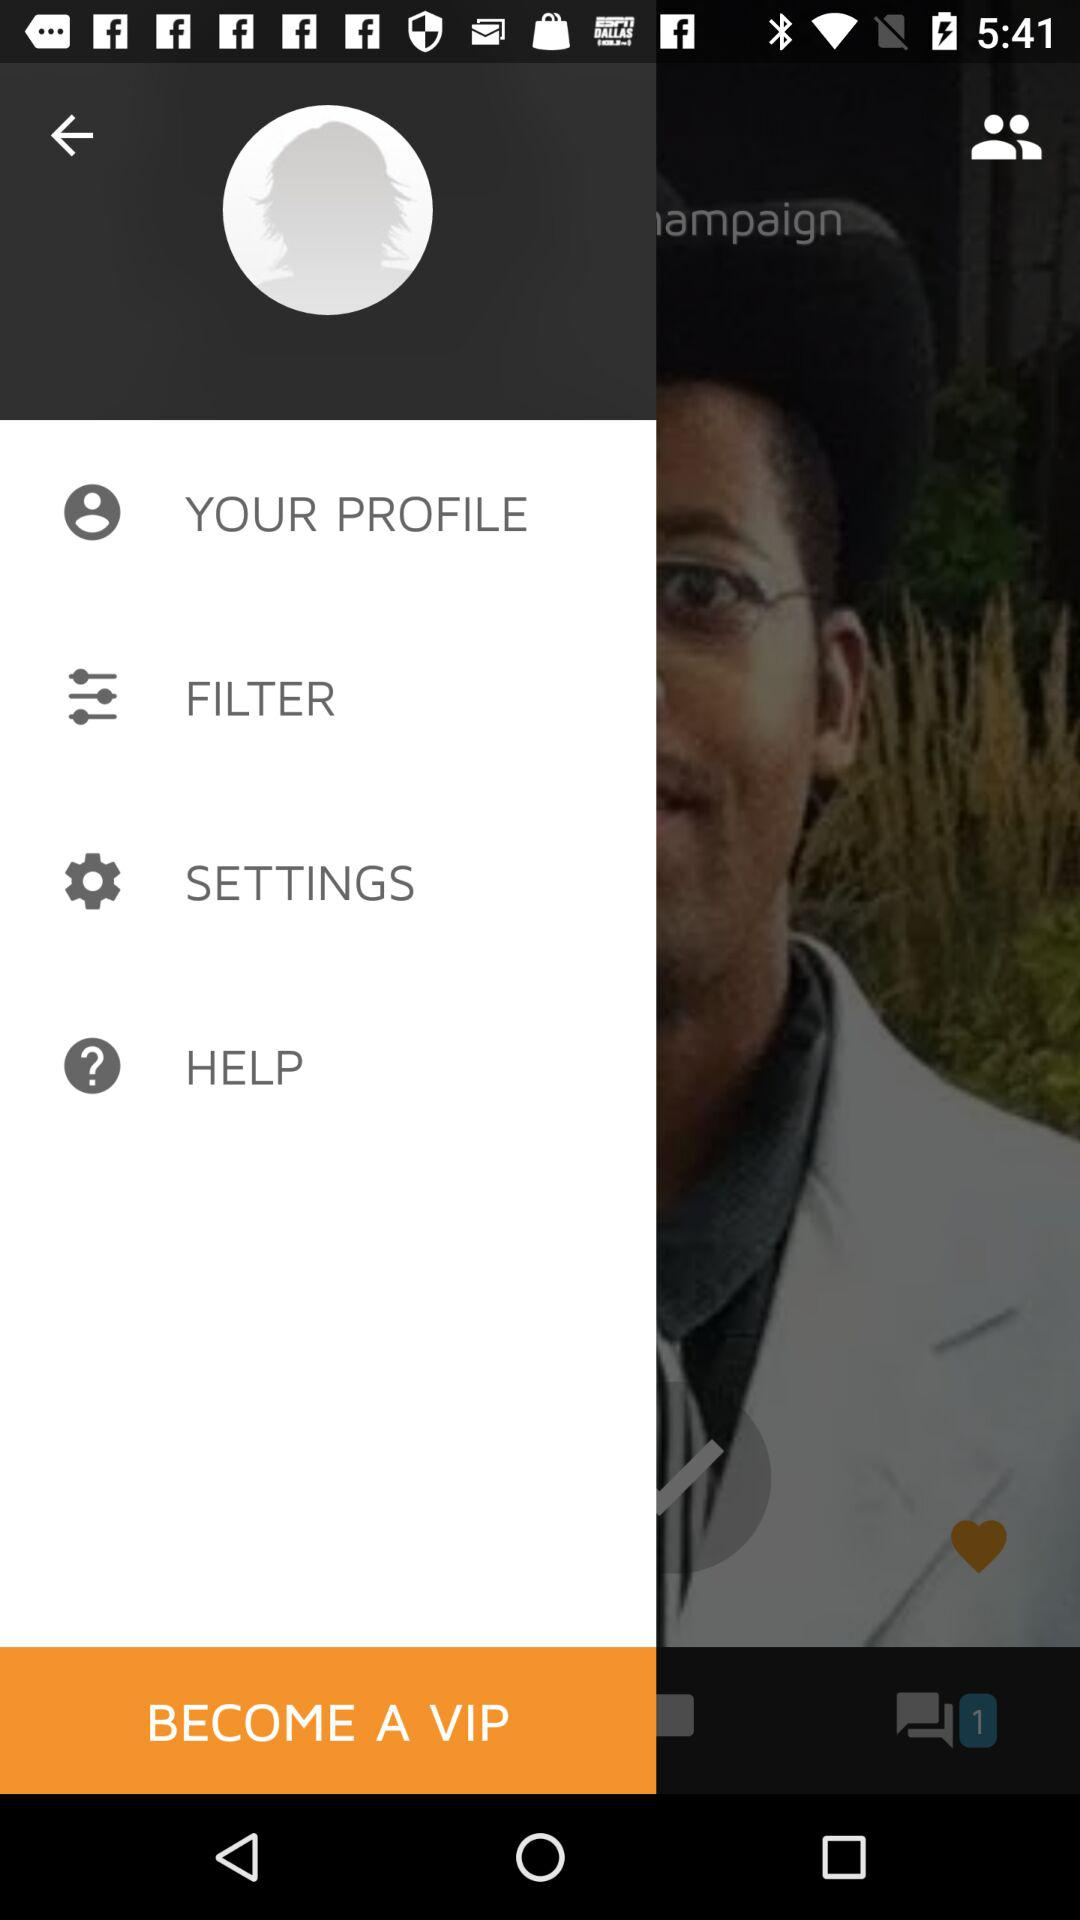How many comments are there? There is only 1 comment. 